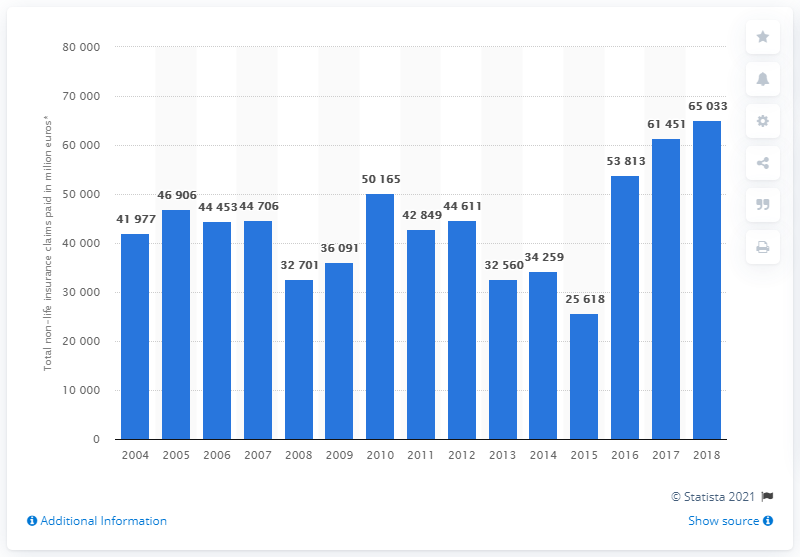Indicate a few pertinent items in this graphic. In 2018, the total amount of non-life insurance claims paid was 65,033. 